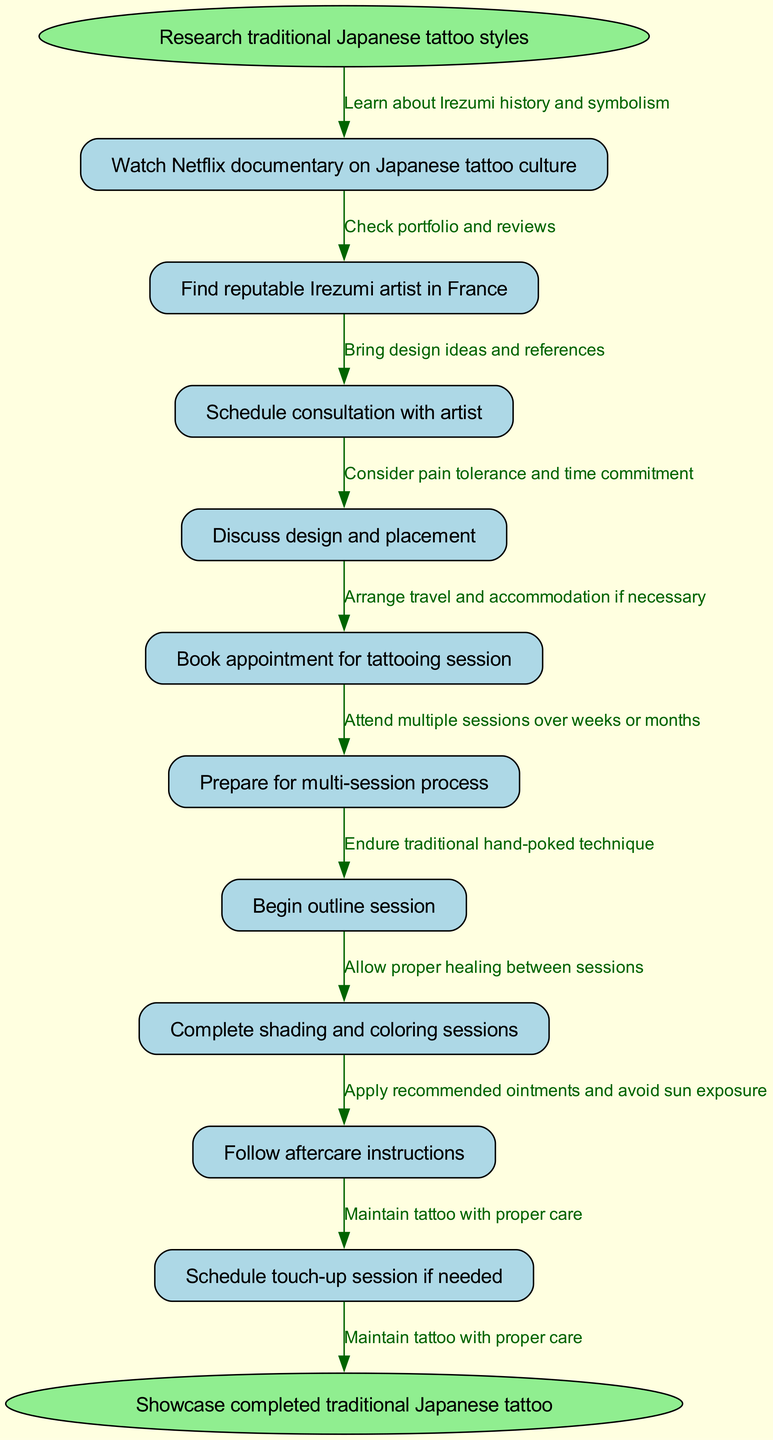What is the starting point of the clinical pathway? The starting point is clearly labeled in the diagram as the node that begins the process, which is "Research traditional Japanese tattoo styles."
Answer: Research traditional Japanese tattoo styles How many nodes are in the diagram? To determine the total number of nodes, count both the start and end nodes along with all the intermediate nodes. There is one start node, nine intermediate nodes, and one end node, making a total of eleven nodes.
Answer: 11 What is the last step before showcasing the completed tattoo? The step that directly precedes showcasing the completed tattoo is indicated in the diagram as the last node before the end, which is "Schedule touch-up session if needed."
Answer: Schedule touch-up session if needed What edge connects "Discuss design and placement" to the next node? The edge connecting "Discuss design and placement" to the next node is labeled "Consider pain tolerance and time commitment," showing the reasoning for moving to the next step.
Answer: Consider pain tolerance and time commitment Which session is designated as the first part of the tattooing process? The first part of the tattooing process is pointed out in the diagram as "Begin outline session," which indicates the initial stage of the tattooing journey.
Answer: Begin outline session What is required after completing the shading and coloring sessions? The requirements following the shading and coloring sessions are articulated in the diagram as "Follow aftercare instructions," which denotes the necessary care to ensure healing.
Answer: Follow aftercare instructions How many edges are illustrated in the diagram? To find the number of edges, consider each connection between nodes. Since there are eleven nodes and the diagram connects each node in a linear sequence, there will be two edges for each of the nine intermediate connections, resulting in ten edges total.
Answer: 10 What does the node "Find reputable Irezumi artist in France" focus on? This node emphasizes the task of locating a skilled tattoo artist who specializes in Irezumi within France, underscoring the importance of artist selection in the process.
Answer: Find reputable Irezumi artist in France What does the edge from "Prepare for multi-session process" imply? The edge from "Prepare for multi-session process" indicates that the process will require several visits over a period of weeks or months, demonstrating the time commitment needed for traditional tattooing.
Answer: Attend multiple sessions over weeks or months 